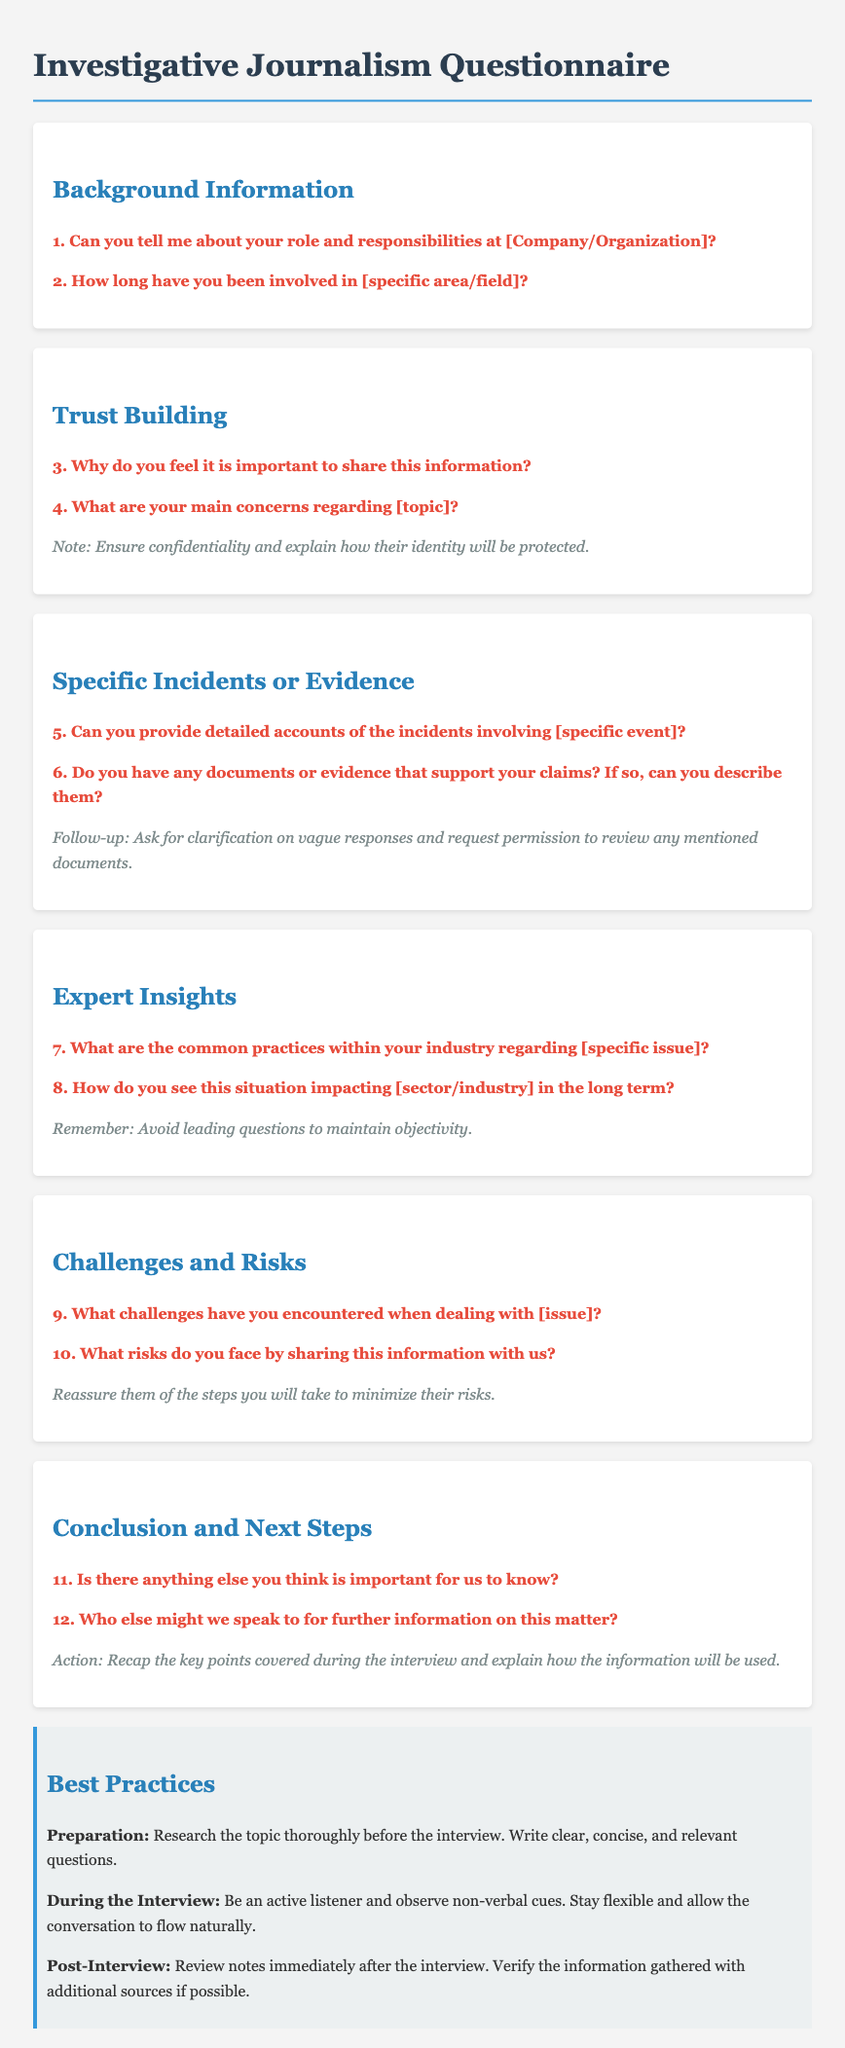What is the title of the document? The title refers to the main subject of the document as stated in the header.
Answer: Investigative Journalism Questionnaire How many sections are in the document? The number of sections can be identified by counting the distinct headings.
Answer: 6 What is one of the questions in the Trust Building section? Identifying specific questions helps understand the focus of this section.
Answer: Why do you feel it is important to share this information? What is mentioned in the tip under Specific Incidents or Evidence? This tip provides guidance on how to handle responses during the interview.
Answer: Follow-up: Ask for clarification on vague responses and request permission to review any mentioned documents What is the focus of the Best Practices section? The focus is on guidelines for conducting interviews effectively.
Answer: Preparation, During the Interview, Post-Interview What is a concern mentioned in the Challenges and Risks section? The question aims to uncover specific issues interviewees may face.
Answer: What risks do you face by sharing this information with us? What is one way to build trust according to the questionnaire? This question pinpoints a strategy for ensuring the interviewee feels secure.
Answer: Ensure confidentiality and explain how their identity will be protected What type of information is sought in the Expert Insights section? This section seeks analysis and insights from those experienced in the field.
Answer: Common practices and impact on the industry 